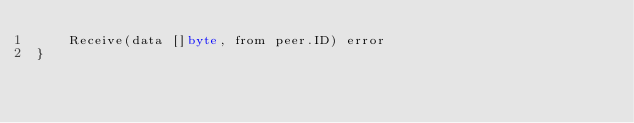Convert code to text. <code><loc_0><loc_0><loc_500><loc_500><_Go_>	Receive(data []byte, from peer.ID) error
}
</code> 